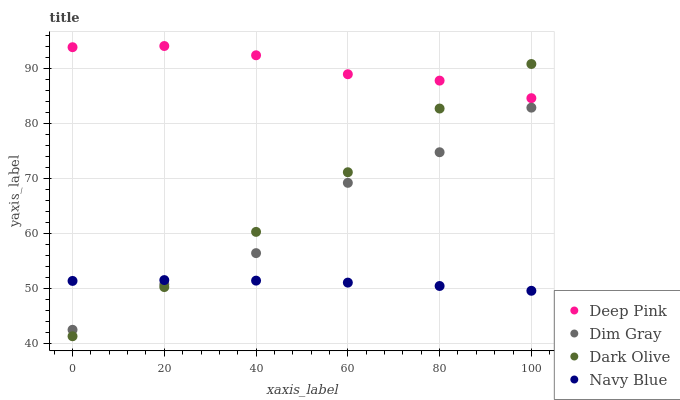Does Navy Blue have the minimum area under the curve?
Answer yes or no. Yes. Does Deep Pink have the maximum area under the curve?
Answer yes or no. Yes. Does Dim Gray have the minimum area under the curve?
Answer yes or no. No. Does Dim Gray have the maximum area under the curve?
Answer yes or no. No. Is Navy Blue the smoothest?
Answer yes or no. Yes. Is Dim Gray the roughest?
Answer yes or no. Yes. Is Dim Gray the smoothest?
Answer yes or no. No. Is Navy Blue the roughest?
Answer yes or no. No. Does Dark Olive have the lowest value?
Answer yes or no. Yes. Does Navy Blue have the lowest value?
Answer yes or no. No. Does Deep Pink have the highest value?
Answer yes or no. Yes. Does Dim Gray have the highest value?
Answer yes or no. No. Is Navy Blue less than Deep Pink?
Answer yes or no. Yes. Is Deep Pink greater than Navy Blue?
Answer yes or no. Yes. Does Deep Pink intersect Dark Olive?
Answer yes or no. Yes. Is Deep Pink less than Dark Olive?
Answer yes or no. No. Is Deep Pink greater than Dark Olive?
Answer yes or no. No. Does Navy Blue intersect Deep Pink?
Answer yes or no. No. 